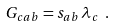<formula> <loc_0><loc_0><loc_500><loc_500>G _ { c a b } = s _ { a b } \, \lambda _ { c } \ .</formula> 